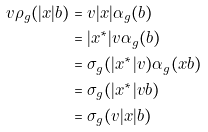<formula> <loc_0><loc_0><loc_500><loc_500>v \rho _ { g } ( | x | b ) & = v | x | \alpha _ { g } ( b ) \\ & = | x ^ { * } | v \alpha _ { g } ( b ) \\ & = \sigma _ { g } ( | x ^ { * } | v ) \alpha _ { g } ( x b ) \\ & = \sigma _ { g } ( | x ^ { * } | v b ) \\ & = \sigma _ { g } ( v | x | b )</formula> 